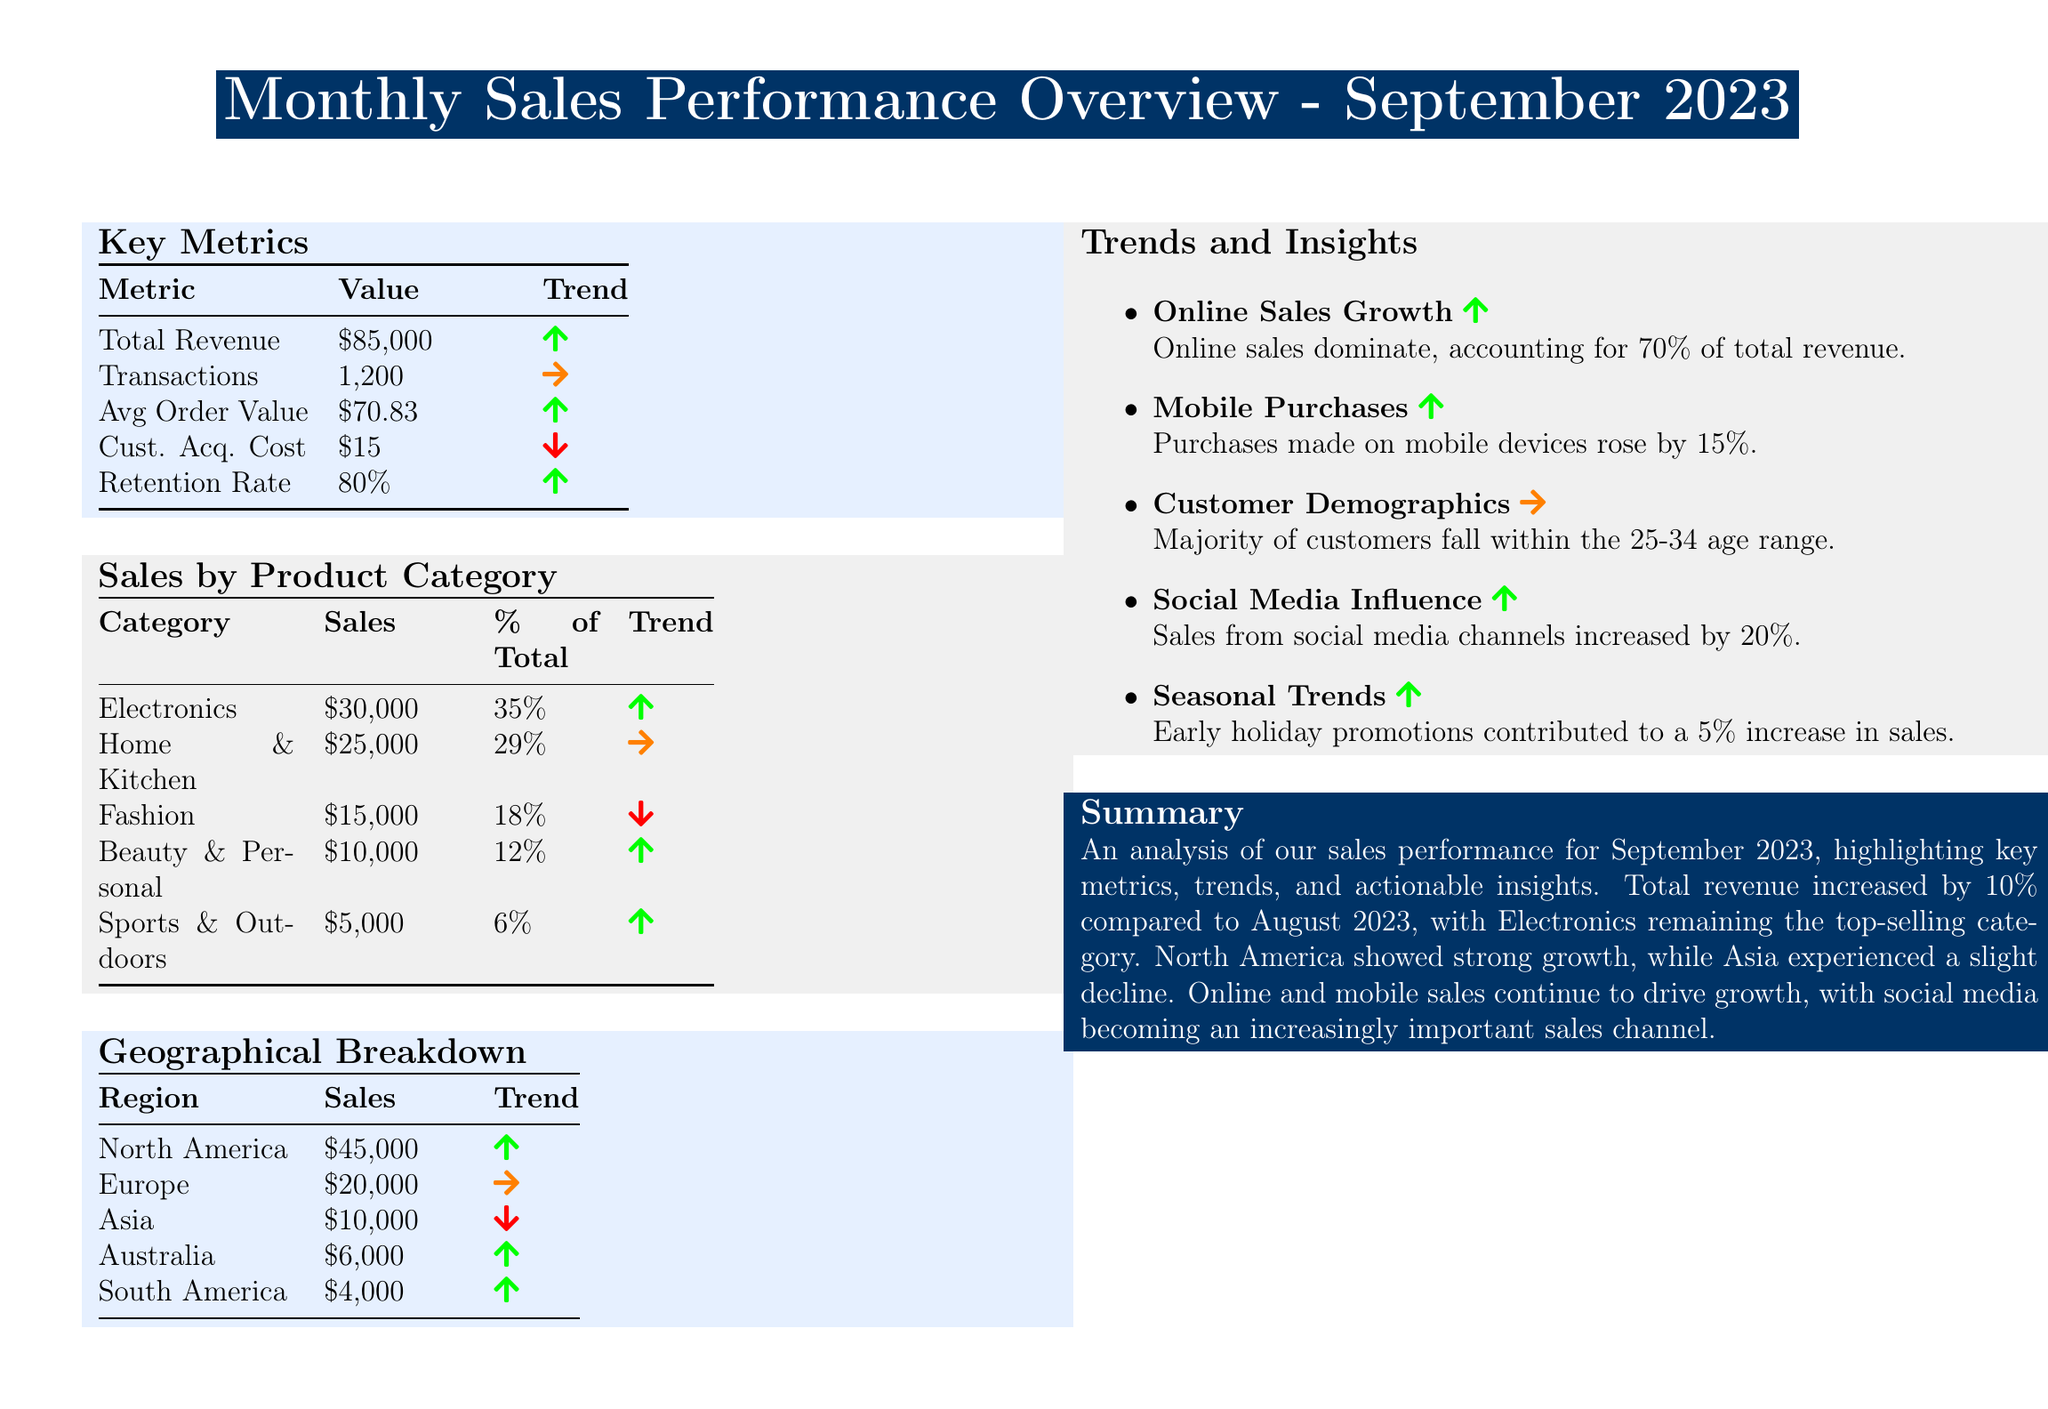what is the total revenue? The total revenue is the value listed under the Key Metrics section, which is \$85,000.
Answer: \$85,000 how many transactions were recorded? The number of transactions is specified in the Key Metrics section as 1,200.
Answer: 1,200 what is the average order value? The average order value is derived from the Key Metrics section, which states it is \$70.83.
Answer: \$70.83 which product category had the highest sales? The highest sales category is identified under the Sales by Product Category section, which is Electronics at \$30,000.
Answer: Electronics what percentage of total sales came from the Fashion category? The percentage for the Fashion category is indicated in the Sales by Product Category section as 18%.
Answer: 18% which region generated the least sales? The region with the least sales is provided in the Geographical Breakdown section, which shows South America at \$4,000.
Answer: South America what trend does the Online Sales Growth exhibit? The trend for Online Sales Growth is indicated as positive in the Trends and Insights section.
Answer: Up how did mobile purchases change? The item related to mobile purchases indicates a growth of 15%, showing a positive change.
Answer: 15% is there an increase in sales from social media channels? The information in the document states that sales from social media channels increased by 20%.
Answer: 20% 